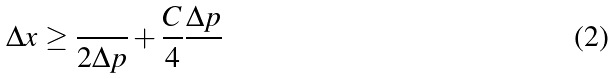Convert formula to latex. <formula><loc_0><loc_0><loc_500><loc_500>\Delta x \geq \frac { } { 2 \Delta p } + \frac { C } { 4 } \frac { \Delta p } { }</formula> 